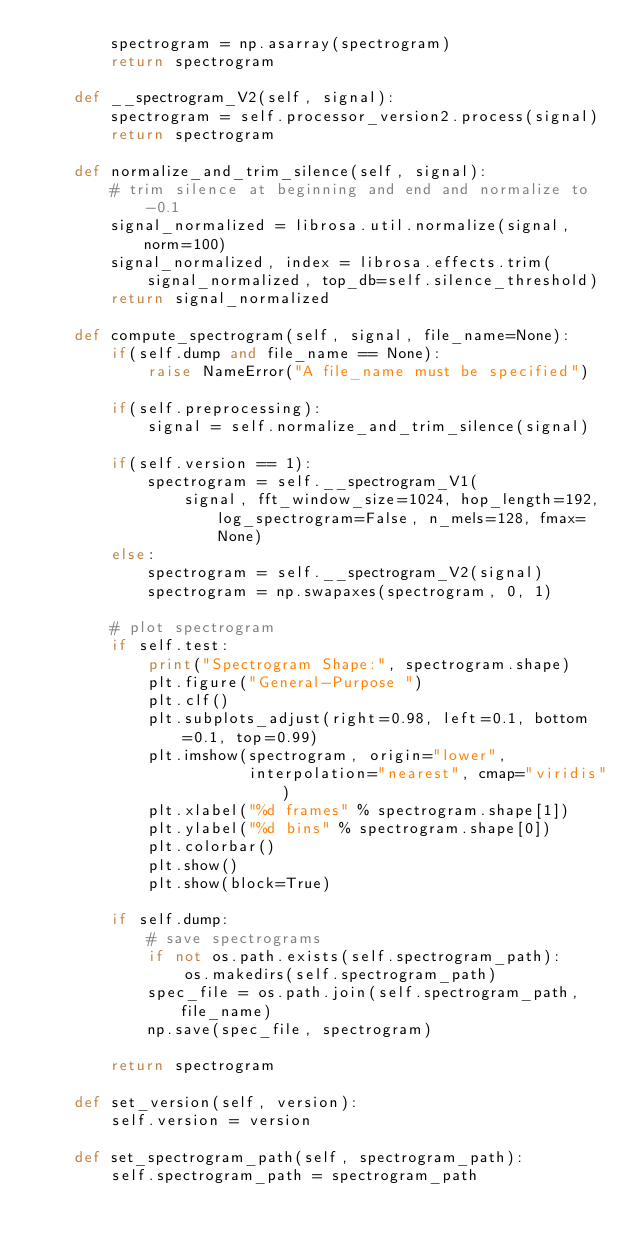<code> <loc_0><loc_0><loc_500><loc_500><_Python_>        spectrogram = np.asarray(spectrogram)
        return spectrogram

    def __spectrogram_V2(self, signal):
        spectrogram = self.processor_version2.process(signal)
        return spectrogram

    def normalize_and_trim_silence(self, signal):
        # trim silence at beginning and end and normalize to -0.1
        signal_normalized = librosa.util.normalize(signal, norm=100)
        signal_normalized, index = librosa.effects.trim(
            signal_normalized, top_db=self.silence_threshold)
        return signal_normalized

    def compute_spectrogram(self, signal, file_name=None):
        if(self.dump and file_name == None):
            raise NameError("A file_name must be specified")

        if(self.preprocessing):
            signal = self.normalize_and_trim_silence(signal)

        if(self.version == 1):
            spectrogram = self.__spectrogram_V1(
                signal, fft_window_size=1024, hop_length=192, log_spectrogram=False, n_mels=128, fmax=None)
        else:
            spectrogram = self.__spectrogram_V2(signal)
            spectrogram = np.swapaxes(spectrogram, 0, 1)

        # plot spectrogram
        if self.test:
            print("Spectrogram Shape:", spectrogram.shape)
            plt.figure("General-Purpose ")
            plt.clf()
            plt.subplots_adjust(right=0.98, left=0.1, bottom=0.1, top=0.99)
            plt.imshow(spectrogram, origin="lower",
                       interpolation="nearest", cmap="viridis")
            plt.xlabel("%d frames" % spectrogram.shape[1])
            plt.ylabel("%d bins" % spectrogram.shape[0])
            plt.colorbar()
            plt.show()
            plt.show(block=True)

        if self.dump:
            # save spectrograms
            if not os.path.exists(self.spectrogram_path):
                os.makedirs(self.spectrogram_path)
            spec_file = os.path.join(self.spectrogram_path, file_name)
            np.save(spec_file, spectrogram)

        return spectrogram

    def set_version(self, version):
        self.version = version

    def set_spectrogram_path(self, spectrogram_path):
        self.spectrogram_path = spectrogram_path
</code> 